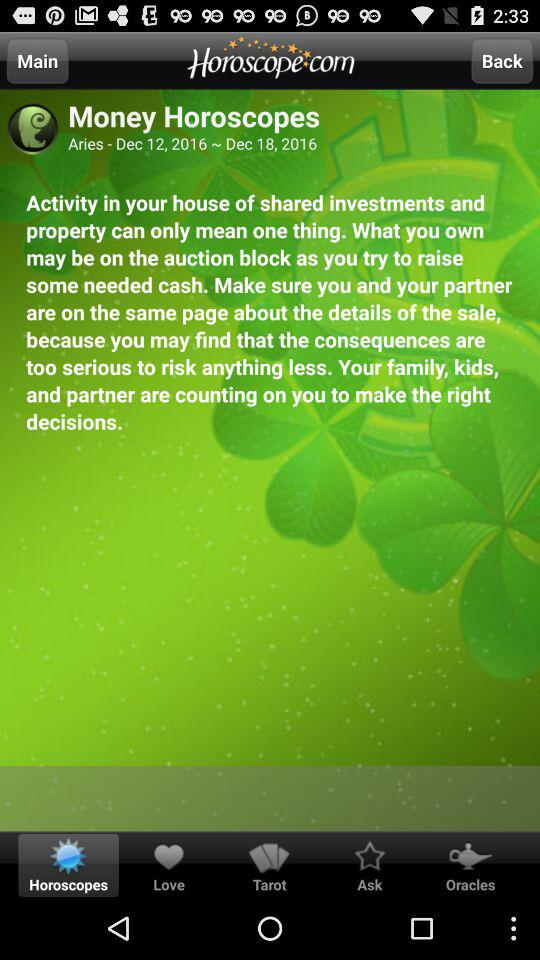What is Aries' tarot reading?
When the provided information is insufficient, respond with <no answer>. <no answer> 